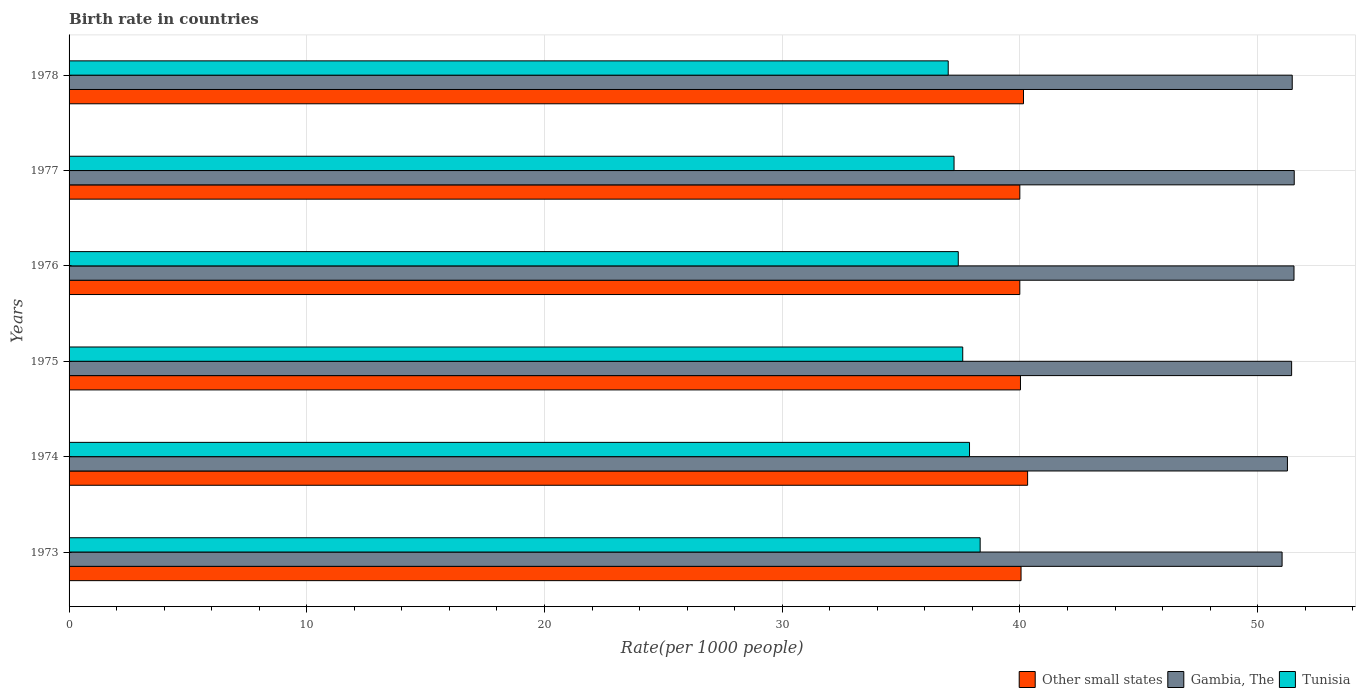How many groups of bars are there?
Keep it short and to the point. 6. Are the number of bars per tick equal to the number of legend labels?
Make the answer very short. Yes. How many bars are there on the 2nd tick from the top?
Your answer should be very brief. 3. How many bars are there on the 5th tick from the bottom?
Your answer should be compact. 3. What is the label of the 5th group of bars from the top?
Ensure brevity in your answer.  1974. What is the birth rate in Other small states in 1976?
Provide a succinct answer. 39.99. Across all years, what is the maximum birth rate in Other small states?
Keep it short and to the point. 40.32. Across all years, what is the minimum birth rate in Gambia, The?
Make the answer very short. 51.03. In which year was the birth rate in Tunisia maximum?
Offer a terse response. 1973. In which year was the birth rate in Gambia, The minimum?
Provide a succinct answer. 1973. What is the total birth rate in Tunisia in the graph?
Your answer should be compact. 225.42. What is the difference between the birth rate in Tunisia in 1974 and that in 1975?
Ensure brevity in your answer.  0.28. What is the difference between the birth rate in Other small states in 1973 and the birth rate in Gambia, The in 1975?
Offer a terse response. -11.38. What is the average birth rate in Tunisia per year?
Provide a succinct answer. 37.57. In the year 1977, what is the difference between the birth rate in Other small states and birth rate in Tunisia?
Make the answer very short. 2.77. In how many years, is the birth rate in Gambia, The greater than 50 ?
Provide a short and direct response. 6. What is the ratio of the birth rate in Other small states in 1975 to that in 1978?
Ensure brevity in your answer.  1. Is the birth rate in Gambia, The in 1973 less than that in 1978?
Give a very brief answer. Yes. Is the difference between the birth rate in Other small states in 1975 and 1977 greater than the difference between the birth rate in Tunisia in 1975 and 1977?
Give a very brief answer. No. What is the difference between the highest and the second highest birth rate in Tunisia?
Give a very brief answer. 0.45. What is the difference between the highest and the lowest birth rate in Other small states?
Give a very brief answer. 0.33. What does the 3rd bar from the top in 1974 represents?
Provide a short and direct response. Other small states. What does the 3rd bar from the bottom in 1973 represents?
Your response must be concise. Tunisia. Is it the case that in every year, the sum of the birth rate in Other small states and birth rate in Tunisia is greater than the birth rate in Gambia, The?
Give a very brief answer. Yes. Are all the bars in the graph horizontal?
Your response must be concise. Yes. How many years are there in the graph?
Ensure brevity in your answer.  6. Does the graph contain grids?
Your answer should be very brief. Yes. Where does the legend appear in the graph?
Offer a very short reply. Bottom right. How are the legend labels stacked?
Your answer should be very brief. Horizontal. What is the title of the graph?
Ensure brevity in your answer.  Birth rate in countries. What is the label or title of the X-axis?
Your response must be concise. Rate(per 1000 people). What is the label or title of the Y-axis?
Offer a terse response. Years. What is the Rate(per 1000 people) of Other small states in 1973?
Provide a short and direct response. 40.05. What is the Rate(per 1000 people) of Gambia, The in 1973?
Keep it short and to the point. 51.03. What is the Rate(per 1000 people) of Tunisia in 1973?
Ensure brevity in your answer.  38.33. What is the Rate(per 1000 people) of Other small states in 1974?
Your answer should be compact. 40.32. What is the Rate(per 1000 people) in Gambia, The in 1974?
Your answer should be very brief. 51.25. What is the Rate(per 1000 people) of Tunisia in 1974?
Your answer should be very brief. 37.88. What is the Rate(per 1000 people) in Other small states in 1975?
Your answer should be compact. 40.02. What is the Rate(per 1000 people) of Gambia, The in 1975?
Ensure brevity in your answer.  51.43. What is the Rate(per 1000 people) of Tunisia in 1975?
Keep it short and to the point. 37.59. What is the Rate(per 1000 people) in Other small states in 1976?
Offer a terse response. 39.99. What is the Rate(per 1000 people) in Gambia, The in 1976?
Offer a terse response. 51.53. What is the Rate(per 1000 people) of Tunisia in 1976?
Provide a succinct answer. 37.41. What is the Rate(per 1000 people) in Other small states in 1977?
Offer a terse response. 40. What is the Rate(per 1000 people) of Gambia, The in 1977?
Offer a very short reply. 51.54. What is the Rate(per 1000 people) in Tunisia in 1977?
Provide a short and direct response. 37.23. What is the Rate(per 1000 people) in Other small states in 1978?
Give a very brief answer. 40.15. What is the Rate(per 1000 people) in Gambia, The in 1978?
Offer a terse response. 51.45. What is the Rate(per 1000 people) in Tunisia in 1978?
Offer a very short reply. 36.98. Across all years, what is the maximum Rate(per 1000 people) of Other small states?
Make the answer very short. 40.32. Across all years, what is the maximum Rate(per 1000 people) in Gambia, The?
Make the answer very short. 51.54. Across all years, what is the maximum Rate(per 1000 people) of Tunisia?
Provide a short and direct response. 38.33. Across all years, what is the minimum Rate(per 1000 people) of Other small states?
Offer a terse response. 39.99. Across all years, what is the minimum Rate(per 1000 people) in Gambia, The?
Ensure brevity in your answer.  51.03. Across all years, what is the minimum Rate(per 1000 people) of Tunisia?
Offer a very short reply. 36.98. What is the total Rate(per 1000 people) of Other small states in the graph?
Keep it short and to the point. 240.53. What is the total Rate(per 1000 people) of Gambia, The in the graph?
Ensure brevity in your answer.  308.23. What is the total Rate(per 1000 people) in Tunisia in the graph?
Offer a very short reply. 225.42. What is the difference between the Rate(per 1000 people) in Other small states in 1973 and that in 1974?
Make the answer very short. -0.28. What is the difference between the Rate(per 1000 people) in Gambia, The in 1973 and that in 1974?
Offer a terse response. -0.23. What is the difference between the Rate(per 1000 people) in Tunisia in 1973 and that in 1974?
Your answer should be compact. 0.45. What is the difference between the Rate(per 1000 people) in Other small states in 1973 and that in 1975?
Your answer should be very brief. 0.02. What is the difference between the Rate(per 1000 people) in Gambia, The in 1973 and that in 1975?
Give a very brief answer. -0.4. What is the difference between the Rate(per 1000 people) of Tunisia in 1973 and that in 1975?
Keep it short and to the point. 0.73. What is the difference between the Rate(per 1000 people) of Other small states in 1973 and that in 1976?
Your answer should be compact. 0.05. What is the difference between the Rate(per 1000 people) in Gambia, The in 1973 and that in 1976?
Offer a very short reply. -0.5. What is the difference between the Rate(per 1000 people) in Tunisia in 1973 and that in 1976?
Your answer should be compact. 0.92. What is the difference between the Rate(per 1000 people) of Other small states in 1973 and that in 1977?
Ensure brevity in your answer.  0.05. What is the difference between the Rate(per 1000 people) of Gambia, The in 1973 and that in 1977?
Provide a short and direct response. -0.51. What is the difference between the Rate(per 1000 people) in Tunisia in 1973 and that in 1977?
Provide a succinct answer. 1.1. What is the difference between the Rate(per 1000 people) in Other small states in 1973 and that in 1978?
Your answer should be compact. -0.1. What is the difference between the Rate(per 1000 people) in Gambia, The in 1973 and that in 1978?
Offer a very short reply. -0.43. What is the difference between the Rate(per 1000 people) of Tunisia in 1973 and that in 1978?
Give a very brief answer. 1.34. What is the difference between the Rate(per 1000 people) in Other small states in 1974 and that in 1975?
Your response must be concise. 0.3. What is the difference between the Rate(per 1000 people) of Gambia, The in 1974 and that in 1975?
Provide a succinct answer. -0.18. What is the difference between the Rate(per 1000 people) in Tunisia in 1974 and that in 1975?
Provide a succinct answer. 0.28. What is the difference between the Rate(per 1000 people) of Other small states in 1974 and that in 1976?
Provide a succinct answer. 0.33. What is the difference between the Rate(per 1000 people) in Gambia, The in 1974 and that in 1976?
Make the answer very short. -0.28. What is the difference between the Rate(per 1000 people) in Tunisia in 1974 and that in 1976?
Offer a terse response. 0.47. What is the difference between the Rate(per 1000 people) of Other small states in 1974 and that in 1977?
Keep it short and to the point. 0.33. What is the difference between the Rate(per 1000 people) in Gambia, The in 1974 and that in 1977?
Provide a short and direct response. -0.29. What is the difference between the Rate(per 1000 people) in Tunisia in 1974 and that in 1977?
Your answer should be very brief. 0.65. What is the difference between the Rate(per 1000 people) of Other small states in 1974 and that in 1978?
Ensure brevity in your answer.  0.17. What is the difference between the Rate(per 1000 people) of Gambia, The in 1974 and that in 1978?
Your answer should be very brief. -0.2. What is the difference between the Rate(per 1000 people) of Tunisia in 1974 and that in 1978?
Your answer should be very brief. 0.9. What is the difference between the Rate(per 1000 people) of Other small states in 1975 and that in 1976?
Ensure brevity in your answer.  0.03. What is the difference between the Rate(per 1000 people) of Gambia, The in 1975 and that in 1976?
Your response must be concise. -0.1. What is the difference between the Rate(per 1000 people) in Tunisia in 1975 and that in 1976?
Keep it short and to the point. 0.19. What is the difference between the Rate(per 1000 people) of Other small states in 1975 and that in 1977?
Make the answer very short. 0.03. What is the difference between the Rate(per 1000 people) of Gambia, The in 1975 and that in 1977?
Your answer should be very brief. -0.11. What is the difference between the Rate(per 1000 people) of Tunisia in 1975 and that in 1977?
Your response must be concise. 0.37. What is the difference between the Rate(per 1000 people) of Other small states in 1975 and that in 1978?
Ensure brevity in your answer.  -0.13. What is the difference between the Rate(per 1000 people) in Gambia, The in 1975 and that in 1978?
Provide a succinct answer. -0.03. What is the difference between the Rate(per 1000 people) of Tunisia in 1975 and that in 1978?
Make the answer very short. 0.61. What is the difference between the Rate(per 1000 people) of Other small states in 1976 and that in 1977?
Keep it short and to the point. -0. What is the difference between the Rate(per 1000 people) of Gambia, The in 1976 and that in 1977?
Offer a very short reply. -0.01. What is the difference between the Rate(per 1000 people) of Tunisia in 1976 and that in 1977?
Your answer should be compact. 0.18. What is the difference between the Rate(per 1000 people) of Other small states in 1976 and that in 1978?
Ensure brevity in your answer.  -0.16. What is the difference between the Rate(per 1000 people) of Gambia, The in 1976 and that in 1978?
Ensure brevity in your answer.  0.07. What is the difference between the Rate(per 1000 people) in Tunisia in 1976 and that in 1978?
Provide a succinct answer. 0.42. What is the difference between the Rate(per 1000 people) in Other small states in 1977 and that in 1978?
Your answer should be compact. -0.15. What is the difference between the Rate(per 1000 people) in Gambia, The in 1977 and that in 1978?
Offer a very short reply. 0.08. What is the difference between the Rate(per 1000 people) of Tunisia in 1977 and that in 1978?
Your response must be concise. 0.24. What is the difference between the Rate(per 1000 people) in Other small states in 1973 and the Rate(per 1000 people) in Gambia, The in 1974?
Give a very brief answer. -11.21. What is the difference between the Rate(per 1000 people) in Other small states in 1973 and the Rate(per 1000 people) in Tunisia in 1974?
Give a very brief answer. 2.17. What is the difference between the Rate(per 1000 people) in Gambia, The in 1973 and the Rate(per 1000 people) in Tunisia in 1974?
Provide a succinct answer. 13.15. What is the difference between the Rate(per 1000 people) in Other small states in 1973 and the Rate(per 1000 people) in Gambia, The in 1975?
Offer a very short reply. -11.38. What is the difference between the Rate(per 1000 people) in Other small states in 1973 and the Rate(per 1000 people) in Tunisia in 1975?
Give a very brief answer. 2.45. What is the difference between the Rate(per 1000 people) of Gambia, The in 1973 and the Rate(per 1000 people) of Tunisia in 1975?
Your answer should be compact. 13.43. What is the difference between the Rate(per 1000 people) of Other small states in 1973 and the Rate(per 1000 people) of Gambia, The in 1976?
Make the answer very short. -11.48. What is the difference between the Rate(per 1000 people) in Other small states in 1973 and the Rate(per 1000 people) in Tunisia in 1976?
Offer a terse response. 2.64. What is the difference between the Rate(per 1000 people) of Gambia, The in 1973 and the Rate(per 1000 people) of Tunisia in 1976?
Ensure brevity in your answer.  13.62. What is the difference between the Rate(per 1000 people) of Other small states in 1973 and the Rate(per 1000 people) of Gambia, The in 1977?
Offer a very short reply. -11.49. What is the difference between the Rate(per 1000 people) of Other small states in 1973 and the Rate(per 1000 people) of Tunisia in 1977?
Ensure brevity in your answer.  2.82. What is the difference between the Rate(per 1000 people) in Other small states in 1973 and the Rate(per 1000 people) in Gambia, The in 1978?
Offer a terse response. -11.41. What is the difference between the Rate(per 1000 people) of Other small states in 1973 and the Rate(per 1000 people) of Tunisia in 1978?
Provide a succinct answer. 3.06. What is the difference between the Rate(per 1000 people) of Gambia, The in 1973 and the Rate(per 1000 people) of Tunisia in 1978?
Provide a succinct answer. 14.04. What is the difference between the Rate(per 1000 people) in Other small states in 1974 and the Rate(per 1000 people) in Gambia, The in 1975?
Your answer should be compact. -11.11. What is the difference between the Rate(per 1000 people) in Other small states in 1974 and the Rate(per 1000 people) in Tunisia in 1975?
Provide a succinct answer. 2.73. What is the difference between the Rate(per 1000 people) of Gambia, The in 1974 and the Rate(per 1000 people) of Tunisia in 1975?
Your answer should be compact. 13.66. What is the difference between the Rate(per 1000 people) of Other small states in 1974 and the Rate(per 1000 people) of Gambia, The in 1976?
Offer a terse response. -11.21. What is the difference between the Rate(per 1000 people) of Other small states in 1974 and the Rate(per 1000 people) of Tunisia in 1976?
Your answer should be very brief. 2.92. What is the difference between the Rate(per 1000 people) of Gambia, The in 1974 and the Rate(per 1000 people) of Tunisia in 1976?
Offer a very short reply. 13.85. What is the difference between the Rate(per 1000 people) in Other small states in 1974 and the Rate(per 1000 people) in Gambia, The in 1977?
Your answer should be very brief. -11.22. What is the difference between the Rate(per 1000 people) of Other small states in 1974 and the Rate(per 1000 people) of Tunisia in 1977?
Make the answer very short. 3.09. What is the difference between the Rate(per 1000 people) in Gambia, The in 1974 and the Rate(per 1000 people) in Tunisia in 1977?
Keep it short and to the point. 14.03. What is the difference between the Rate(per 1000 people) in Other small states in 1974 and the Rate(per 1000 people) in Gambia, The in 1978?
Your response must be concise. -11.13. What is the difference between the Rate(per 1000 people) in Other small states in 1974 and the Rate(per 1000 people) in Tunisia in 1978?
Your answer should be compact. 3.34. What is the difference between the Rate(per 1000 people) in Gambia, The in 1974 and the Rate(per 1000 people) in Tunisia in 1978?
Your answer should be compact. 14.27. What is the difference between the Rate(per 1000 people) of Other small states in 1975 and the Rate(per 1000 people) of Gambia, The in 1976?
Your response must be concise. -11.51. What is the difference between the Rate(per 1000 people) in Other small states in 1975 and the Rate(per 1000 people) in Tunisia in 1976?
Ensure brevity in your answer.  2.62. What is the difference between the Rate(per 1000 people) of Gambia, The in 1975 and the Rate(per 1000 people) of Tunisia in 1976?
Give a very brief answer. 14.02. What is the difference between the Rate(per 1000 people) in Other small states in 1975 and the Rate(per 1000 people) in Gambia, The in 1977?
Offer a very short reply. -11.52. What is the difference between the Rate(per 1000 people) of Other small states in 1975 and the Rate(per 1000 people) of Tunisia in 1977?
Your response must be concise. 2.79. What is the difference between the Rate(per 1000 people) in Gambia, The in 1975 and the Rate(per 1000 people) in Tunisia in 1977?
Keep it short and to the point. 14.2. What is the difference between the Rate(per 1000 people) in Other small states in 1975 and the Rate(per 1000 people) in Gambia, The in 1978?
Your answer should be very brief. -11.43. What is the difference between the Rate(per 1000 people) of Other small states in 1975 and the Rate(per 1000 people) of Tunisia in 1978?
Provide a short and direct response. 3.04. What is the difference between the Rate(per 1000 people) of Gambia, The in 1975 and the Rate(per 1000 people) of Tunisia in 1978?
Your answer should be very brief. 14.45. What is the difference between the Rate(per 1000 people) of Other small states in 1976 and the Rate(per 1000 people) of Gambia, The in 1977?
Offer a very short reply. -11.54. What is the difference between the Rate(per 1000 people) of Other small states in 1976 and the Rate(per 1000 people) of Tunisia in 1977?
Provide a short and direct response. 2.77. What is the difference between the Rate(per 1000 people) in Gambia, The in 1976 and the Rate(per 1000 people) in Tunisia in 1977?
Your response must be concise. 14.3. What is the difference between the Rate(per 1000 people) of Other small states in 1976 and the Rate(per 1000 people) of Gambia, The in 1978?
Make the answer very short. -11.46. What is the difference between the Rate(per 1000 people) of Other small states in 1976 and the Rate(per 1000 people) of Tunisia in 1978?
Offer a terse response. 3.01. What is the difference between the Rate(per 1000 people) in Gambia, The in 1976 and the Rate(per 1000 people) in Tunisia in 1978?
Provide a succinct answer. 14.55. What is the difference between the Rate(per 1000 people) of Other small states in 1977 and the Rate(per 1000 people) of Gambia, The in 1978?
Provide a short and direct response. -11.46. What is the difference between the Rate(per 1000 people) in Other small states in 1977 and the Rate(per 1000 people) in Tunisia in 1978?
Give a very brief answer. 3.01. What is the difference between the Rate(per 1000 people) in Gambia, The in 1977 and the Rate(per 1000 people) in Tunisia in 1978?
Your answer should be compact. 14.56. What is the average Rate(per 1000 people) of Other small states per year?
Your answer should be compact. 40.09. What is the average Rate(per 1000 people) in Gambia, The per year?
Your answer should be very brief. 51.37. What is the average Rate(per 1000 people) of Tunisia per year?
Give a very brief answer. 37.57. In the year 1973, what is the difference between the Rate(per 1000 people) of Other small states and Rate(per 1000 people) of Gambia, The?
Ensure brevity in your answer.  -10.98. In the year 1973, what is the difference between the Rate(per 1000 people) of Other small states and Rate(per 1000 people) of Tunisia?
Your answer should be compact. 1.72. In the year 1973, what is the difference between the Rate(per 1000 people) of Gambia, The and Rate(per 1000 people) of Tunisia?
Ensure brevity in your answer.  12.7. In the year 1974, what is the difference between the Rate(per 1000 people) in Other small states and Rate(per 1000 people) in Gambia, The?
Ensure brevity in your answer.  -10.93. In the year 1974, what is the difference between the Rate(per 1000 people) in Other small states and Rate(per 1000 people) in Tunisia?
Your response must be concise. 2.44. In the year 1974, what is the difference between the Rate(per 1000 people) in Gambia, The and Rate(per 1000 people) in Tunisia?
Provide a succinct answer. 13.37. In the year 1975, what is the difference between the Rate(per 1000 people) in Other small states and Rate(per 1000 people) in Gambia, The?
Give a very brief answer. -11.41. In the year 1975, what is the difference between the Rate(per 1000 people) in Other small states and Rate(per 1000 people) in Tunisia?
Provide a short and direct response. 2.43. In the year 1975, what is the difference between the Rate(per 1000 people) of Gambia, The and Rate(per 1000 people) of Tunisia?
Provide a succinct answer. 13.84. In the year 1976, what is the difference between the Rate(per 1000 people) of Other small states and Rate(per 1000 people) of Gambia, The?
Provide a short and direct response. -11.53. In the year 1976, what is the difference between the Rate(per 1000 people) in Other small states and Rate(per 1000 people) in Tunisia?
Make the answer very short. 2.59. In the year 1976, what is the difference between the Rate(per 1000 people) in Gambia, The and Rate(per 1000 people) in Tunisia?
Give a very brief answer. 14.12. In the year 1977, what is the difference between the Rate(per 1000 people) of Other small states and Rate(per 1000 people) of Gambia, The?
Provide a succinct answer. -11.54. In the year 1977, what is the difference between the Rate(per 1000 people) in Other small states and Rate(per 1000 people) in Tunisia?
Make the answer very short. 2.77. In the year 1977, what is the difference between the Rate(per 1000 people) of Gambia, The and Rate(per 1000 people) of Tunisia?
Ensure brevity in your answer.  14.31. In the year 1978, what is the difference between the Rate(per 1000 people) of Other small states and Rate(per 1000 people) of Gambia, The?
Your response must be concise. -11.3. In the year 1978, what is the difference between the Rate(per 1000 people) of Other small states and Rate(per 1000 people) of Tunisia?
Your answer should be very brief. 3.17. In the year 1978, what is the difference between the Rate(per 1000 people) in Gambia, The and Rate(per 1000 people) in Tunisia?
Offer a very short reply. 14.47. What is the ratio of the Rate(per 1000 people) in Other small states in 1973 to that in 1974?
Your answer should be compact. 0.99. What is the ratio of the Rate(per 1000 people) in Tunisia in 1973 to that in 1974?
Your answer should be very brief. 1.01. What is the ratio of the Rate(per 1000 people) of Other small states in 1973 to that in 1975?
Offer a very short reply. 1. What is the ratio of the Rate(per 1000 people) of Gambia, The in 1973 to that in 1975?
Your answer should be very brief. 0.99. What is the ratio of the Rate(per 1000 people) in Tunisia in 1973 to that in 1975?
Your response must be concise. 1.02. What is the ratio of the Rate(per 1000 people) in Other small states in 1973 to that in 1976?
Your answer should be very brief. 1. What is the ratio of the Rate(per 1000 people) in Gambia, The in 1973 to that in 1976?
Give a very brief answer. 0.99. What is the ratio of the Rate(per 1000 people) of Tunisia in 1973 to that in 1976?
Offer a terse response. 1.02. What is the ratio of the Rate(per 1000 people) in Other small states in 1973 to that in 1977?
Your response must be concise. 1. What is the ratio of the Rate(per 1000 people) in Tunisia in 1973 to that in 1977?
Give a very brief answer. 1.03. What is the ratio of the Rate(per 1000 people) of Other small states in 1973 to that in 1978?
Ensure brevity in your answer.  1. What is the ratio of the Rate(per 1000 people) of Gambia, The in 1973 to that in 1978?
Your response must be concise. 0.99. What is the ratio of the Rate(per 1000 people) in Tunisia in 1973 to that in 1978?
Make the answer very short. 1.04. What is the ratio of the Rate(per 1000 people) in Other small states in 1974 to that in 1975?
Provide a short and direct response. 1.01. What is the ratio of the Rate(per 1000 people) in Gambia, The in 1974 to that in 1975?
Offer a very short reply. 1. What is the ratio of the Rate(per 1000 people) in Tunisia in 1974 to that in 1975?
Provide a short and direct response. 1.01. What is the ratio of the Rate(per 1000 people) in Other small states in 1974 to that in 1976?
Make the answer very short. 1.01. What is the ratio of the Rate(per 1000 people) in Tunisia in 1974 to that in 1976?
Your response must be concise. 1.01. What is the ratio of the Rate(per 1000 people) of Other small states in 1974 to that in 1977?
Your response must be concise. 1.01. What is the ratio of the Rate(per 1000 people) of Gambia, The in 1974 to that in 1977?
Your answer should be very brief. 0.99. What is the ratio of the Rate(per 1000 people) of Tunisia in 1974 to that in 1977?
Offer a very short reply. 1.02. What is the ratio of the Rate(per 1000 people) of Other small states in 1974 to that in 1978?
Give a very brief answer. 1. What is the ratio of the Rate(per 1000 people) of Gambia, The in 1974 to that in 1978?
Your answer should be compact. 1. What is the ratio of the Rate(per 1000 people) of Tunisia in 1974 to that in 1978?
Offer a terse response. 1.02. What is the ratio of the Rate(per 1000 people) of Other small states in 1975 to that in 1977?
Offer a very short reply. 1. What is the ratio of the Rate(per 1000 people) of Tunisia in 1975 to that in 1977?
Your answer should be compact. 1.01. What is the ratio of the Rate(per 1000 people) in Tunisia in 1975 to that in 1978?
Give a very brief answer. 1.02. What is the ratio of the Rate(per 1000 people) of Other small states in 1976 to that in 1977?
Ensure brevity in your answer.  1. What is the ratio of the Rate(per 1000 people) in Gambia, The in 1976 to that in 1977?
Provide a short and direct response. 1. What is the ratio of the Rate(per 1000 people) in Tunisia in 1976 to that in 1978?
Offer a terse response. 1.01. What is the ratio of the Rate(per 1000 people) in Other small states in 1977 to that in 1978?
Offer a terse response. 1. What is the ratio of the Rate(per 1000 people) of Tunisia in 1977 to that in 1978?
Your answer should be compact. 1.01. What is the difference between the highest and the second highest Rate(per 1000 people) in Other small states?
Provide a short and direct response. 0.17. What is the difference between the highest and the second highest Rate(per 1000 people) of Gambia, The?
Keep it short and to the point. 0.01. What is the difference between the highest and the second highest Rate(per 1000 people) in Tunisia?
Give a very brief answer. 0.45. What is the difference between the highest and the lowest Rate(per 1000 people) of Other small states?
Make the answer very short. 0.33. What is the difference between the highest and the lowest Rate(per 1000 people) of Gambia, The?
Offer a terse response. 0.51. What is the difference between the highest and the lowest Rate(per 1000 people) of Tunisia?
Make the answer very short. 1.34. 